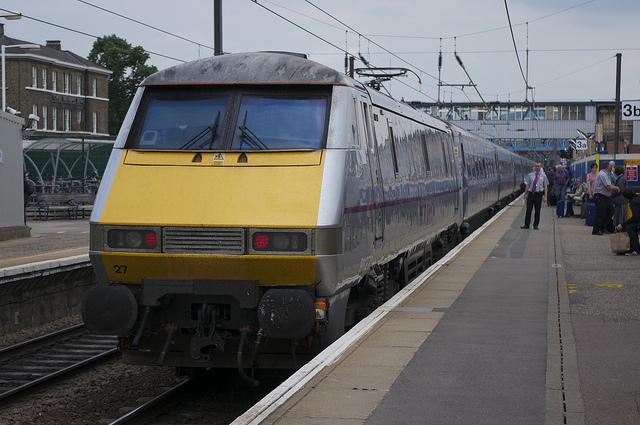Is this a noisy environment?
Short answer required. Yes. Is the train moving fast?
Concise answer only. No. Are people walking near the track?
Concise answer only. Yes. What color is the train?
Quick response, please. Yellow. Is there a fire hydrant pictured?
Keep it brief. No. Are a lot of people waiting to get on?
Concise answer only. No. Is this a modern train?
Quick response, please. Yes. Is the train near the platform?
Keep it brief. Yes. What color is the front part of the train?
Short answer required. Yellow. Is this a toy?
Write a very short answer. No. What season is this?
Be succinct. Spring. Is this train fast or slow?
Write a very short answer. Fast. Is anyone boarding the train?
Be succinct. No. Does the train have its headlights on?
Concise answer only. No. How many people are waiting for the train?
Short answer required. 4. Is the train speeding?
Be succinct. No. Who is the man standing beside the train?
Answer briefly. Conductor. Are there any people here?
Write a very short answer. Yes. Is the train moving?
Keep it brief. No. What are the colors on the train?
Short answer required. Yellow and white. Is this rush hour?
Answer briefly. No. How many wheels do this picture have?
Quick response, please. 0. How many people are on the platform?
Answer briefly. 5. Is the man nearest the yellow train close to the photographer?
Short answer required. No. 